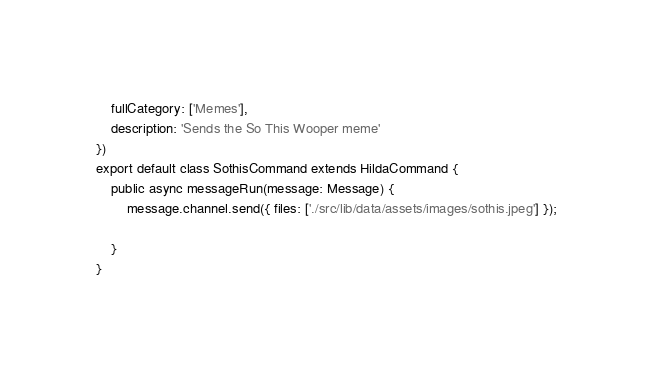<code> <loc_0><loc_0><loc_500><loc_500><_TypeScript_>    fullCategory: ['Memes'],
	description: 'Sends the So This Wooper meme'
})
export default class SothisCommand extends HildaCommand {
    public async messageRun(message: Message) {
        message.channel.send({ files: ['./src/lib/data/assets/images/sothis.jpeg'] });
        
    }
}</code> 